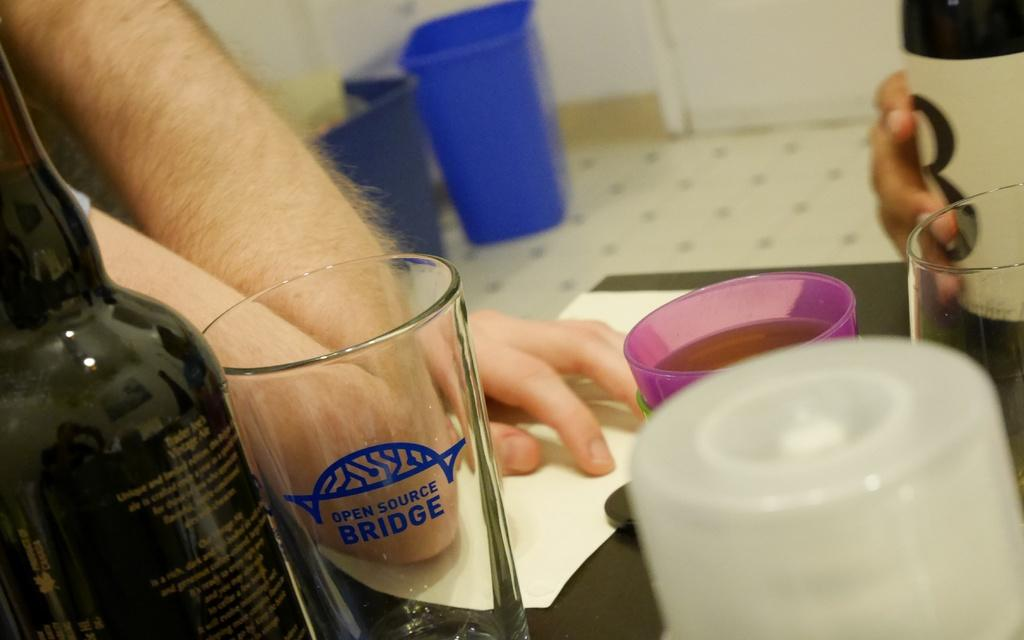<image>
Share a concise interpretation of the image provided. A person's hands are on a table next to a bottle and a glass that reads OPEN SOURCE BRIDGE on it. 